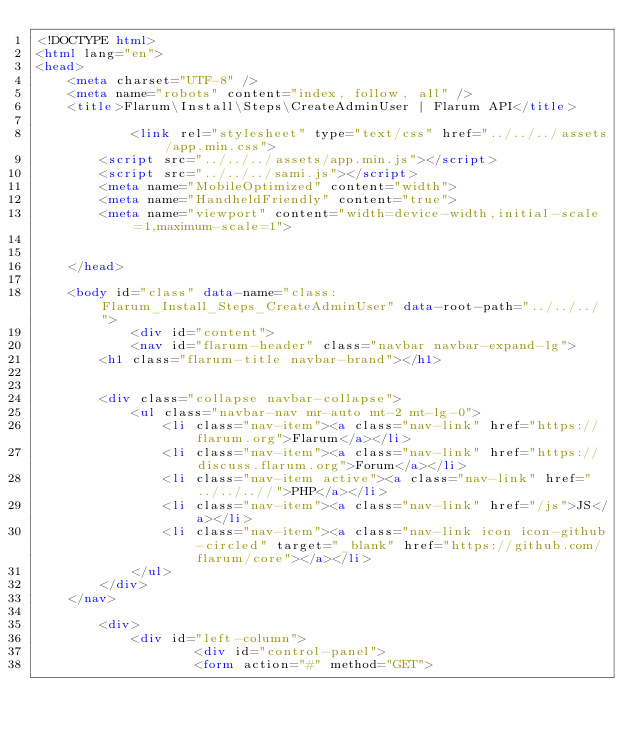Convert code to text. <code><loc_0><loc_0><loc_500><loc_500><_HTML_><!DOCTYPE html>
<html lang="en">
<head>
    <meta charset="UTF-8" />
    <meta name="robots" content="index, follow, all" />
    <title>Flarum\Install\Steps\CreateAdminUser | Flarum API</title>

            <link rel="stylesheet" type="text/css" href="../../../assets/app.min.css">
        <script src="../../../assets/app.min.js"></script>
        <script src="../../../sami.js"></script>
        <meta name="MobileOptimized" content="width">
        <meta name="HandheldFriendly" content="true">
        <meta name="viewport" content="width=device-width,initial-scale=1,maximum-scale=1">
    
    
    </head>

    <body id="class" data-name="class:Flarum_Install_Steps_CreateAdminUser" data-root-path="../../../">
            <div id="content">
            <nav id="flarum-header" class="navbar navbar-expand-lg">
        <h1 class="flarum-title navbar-brand"></h1>

        
        <div class="collapse navbar-collapse">
            <ul class="navbar-nav mr-auto mt-2 mt-lg-0">
                <li class="nav-item"><a class="nav-link" href="https://flarum.org">Flarum</a></li>
                <li class="nav-item"><a class="nav-link" href="https://discuss.flarum.org">Forum</a></li>
                <li class="nav-item active"><a class="nav-link" href="../../..//">PHP</a></li>
                <li class="nav-item"><a class="nav-link" href="/js">JS</a></li>
                <li class="nav-item"><a class="nav-link icon icon-github-circled" target="_blank" href="https://github.com/flarum/core"></a></li>
            </ul>
        </div>
    </nav>

        <div>
            <div id="left-column">
                    <div id="control-panel">
                    <form action="#" method="GET"></code> 